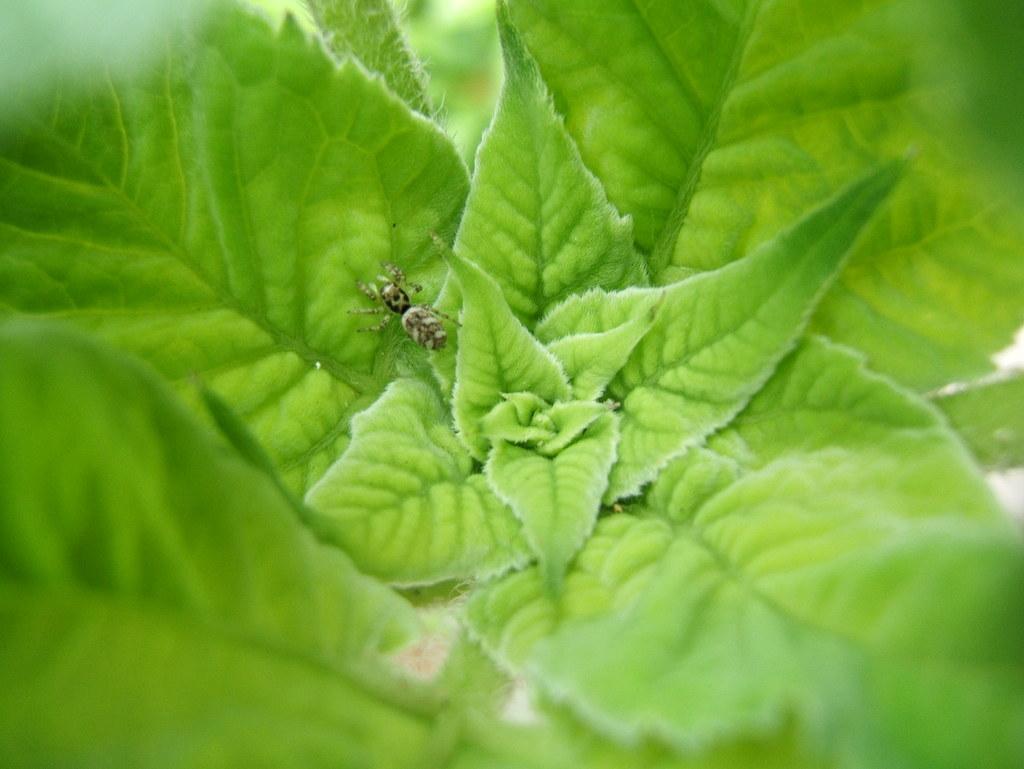How would you summarize this image in a sentence or two? In the picture I can see the green leaves and I can see an insect on the leaf. 